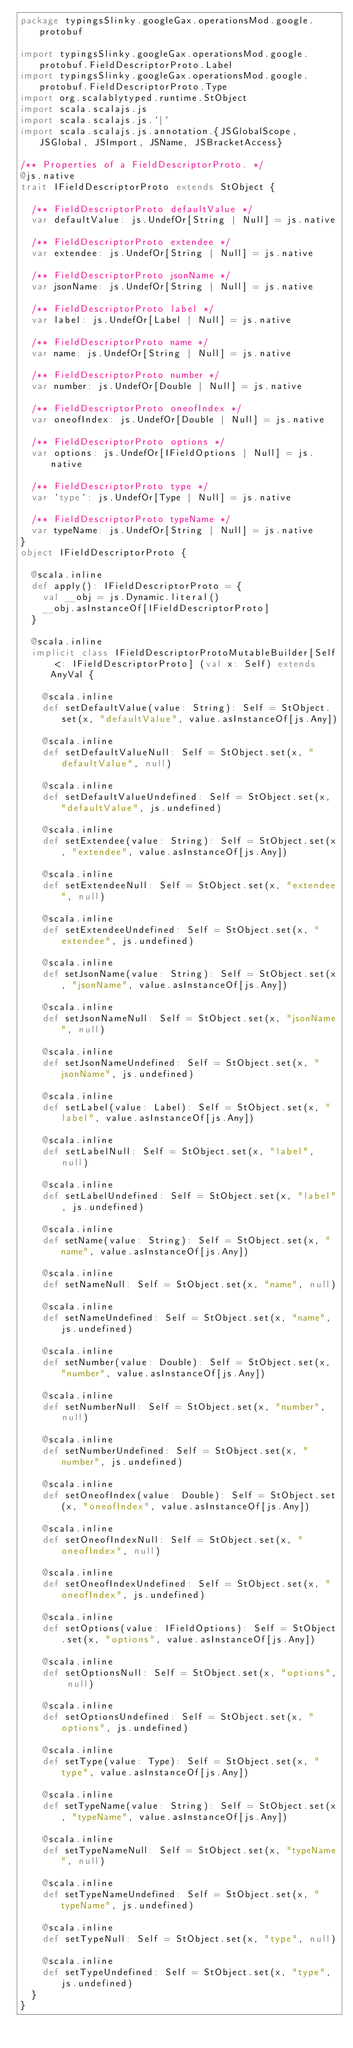<code> <loc_0><loc_0><loc_500><loc_500><_Scala_>package typingsSlinky.googleGax.operationsMod.google.protobuf

import typingsSlinky.googleGax.operationsMod.google.protobuf.FieldDescriptorProto.Label
import typingsSlinky.googleGax.operationsMod.google.protobuf.FieldDescriptorProto.Type
import org.scalablytyped.runtime.StObject
import scala.scalajs.js
import scala.scalajs.js.`|`
import scala.scalajs.js.annotation.{JSGlobalScope, JSGlobal, JSImport, JSName, JSBracketAccess}

/** Properties of a FieldDescriptorProto. */
@js.native
trait IFieldDescriptorProto extends StObject {
  
  /** FieldDescriptorProto defaultValue */
  var defaultValue: js.UndefOr[String | Null] = js.native
  
  /** FieldDescriptorProto extendee */
  var extendee: js.UndefOr[String | Null] = js.native
  
  /** FieldDescriptorProto jsonName */
  var jsonName: js.UndefOr[String | Null] = js.native
  
  /** FieldDescriptorProto label */
  var label: js.UndefOr[Label | Null] = js.native
  
  /** FieldDescriptorProto name */
  var name: js.UndefOr[String | Null] = js.native
  
  /** FieldDescriptorProto number */
  var number: js.UndefOr[Double | Null] = js.native
  
  /** FieldDescriptorProto oneofIndex */
  var oneofIndex: js.UndefOr[Double | Null] = js.native
  
  /** FieldDescriptorProto options */
  var options: js.UndefOr[IFieldOptions | Null] = js.native
  
  /** FieldDescriptorProto type */
  var `type`: js.UndefOr[Type | Null] = js.native
  
  /** FieldDescriptorProto typeName */
  var typeName: js.UndefOr[String | Null] = js.native
}
object IFieldDescriptorProto {
  
  @scala.inline
  def apply(): IFieldDescriptorProto = {
    val __obj = js.Dynamic.literal()
    __obj.asInstanceOf[IFieldDescriptorProto]
  }
  
  @scala.inline
  implicit class IFieldDescriptorProtoMutableBuilder[Self <: IFieldDescriptorProto] (val x: Self) extends AnyVal {
    
    @scala.inline
    def setDefaultValue(value: String): Self = StObject.set(x, "defaultValue", value.asInstanceOf[js.Any])
    
    @scala.inline
    def setDefaultValueNull: Self = StObject.set(x, "defaultValue", null)
    
    @scala.inline
    def setDefaultValueUndefined: Self = StObject.set(x, "defaultValue", js.undefined)
    
    @scala.inline
    def setExtendee(value: String): Self = StObject.set(x, "extendee", value.asInstanceOf[js.Any])
    
    @scala.inline
    def setExtendeeNull: Self = StObject.set(x, "extendee", null)
    
    @scala.inline
    def setExtendeeUndefined: Self = StObject.set(x, "extendee", js.undefined)
    
    @scala.inline
    def setJsonName(value: String): Self = StObject.set(x, "jsonName", value.asInstanceOf[js.Any])
    
    @scala.inline
    def setJsonNameNull: Self = StObject.set(x, "jsonName", null)
    
    @scala.inline
    def setJsonNameUndefined: Self = StObject.set(x, "jsonName", js.undefined)
    
    @scala.inline
    def setLabel(value: Label): Self = StObject.set(x, "label", value.asInstanceOf[js.Any])
    
    @scala.inline
    def setLabelNull: Self = StObject.set(x, "label", null)
    
    @scala.inline
    def setLabelUndefined: Self = StObject.set(x, "label", js.undefined)
    
    @scala.inline
    def setName(value: String): Self = StObject.set(x, "name", value.asInstanceOf[js.Any])
    
    @scala.inline
    def setNameNull: Self = StObject.set(x, "name", null)
    
    @scala.inline
    def setNameUndefined: Self = StObject.set(x, "name", js.undefined)
    
    @scala.inline
    def setNumber(value: Double): Self = StObject.set(x, "number", value.asInstanceOf[js.Any])
    
    @scala.inline
    def setNumberNull: Self = StObject.set(x, "number", null)
    
    @scala.inline
    def setNumberUndefined: Self = StObject.set(x, "number", js.undefined)
    
    @scala.inline
    def setOneofIndex(value: Double): Self = StObject.set(x, "oneofIndex", value.asInstanceOf[js.Any])
    
    @scala.inline
    def setOneofIndexNull: Self = StObject.set(x, "oneofIndex", null)
    
    @scala.inline
    def setOneofIndexUndefined: Self = StObject.set(x, "oneofIndex", js.undefined)
    
    @scala.inline
    def setOptions(value: IFieldOptions): Self = StObject.set(x, "options", value.asInstanceOf[js.Any])
    
    @scala.inline
    def setOptionsNull: Self = StObject.set(x, "options", null)
    
    @scala.inline
    def setOptionsUndefined: Self = StObject.set(x, "options", js.undefined)
    
    @scala.inline
    def setType(value: Type): Self = StObject.set(x, "type", value.asInstanceOf[js.Any])
    
    @scala.inline
    def setTypeName(value: String): Self = StObject.set(x, "typeName", value.asInstanceOf[js.Any])
    
    @scala.inline
    def setTypeNameNull: Self = StObject.set(x, "typeName", null)
    
    @scala.inline
    def setTypeNameUndefined: Self = StObject.set(x, "typeName", js.undefined)
    
    @scala.inline
    def setTypeNull: Self = StObject.set(x, "type", null)
    
    @scala.inline
    def setTypeUndefined: Self = StObject.set(x, "type", js.undefined)
  }
}
</code> 